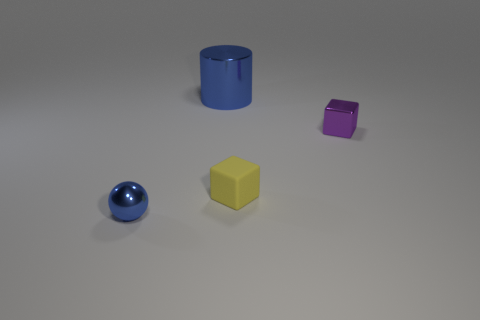Are there any other things that have the same material as the yellow cube?
Your answer should be compact. No. The purple metal thing that is the same size as the blue sphere is what shape?
Your answer should be very brief. Cube. How many objects are things that are in front of the big shiny cylinder or metal objects to the right of the small yellow block?
Offer a terse response. 3. Are there fewer green cylinders than small metal spheres?
Give a very brief answer. Yes. There is a blue object that is the same size as the purple metal thing; what material is it?
Your answer should be compact. Metal. There is a metallic thing behind the purple shiny thing; is it the same size as the blue metallic object in front of the small purple thing?
Your answer should be compact. No. Are there any tiny blue balls made of the same material as the blue cylinder?
Keep it short and to the point. Yes. What number of objects are either objects behind the tiny blue metallic ball or small gray metal things?
Your answer should be very brief. 3. Are the blue thing that is behind the small purple shiny thing and the small yellow block made of the same material?
Make the answer very short. No. Is the small blue thing the same shape as the yellow object?
Your response must be concise. No. 